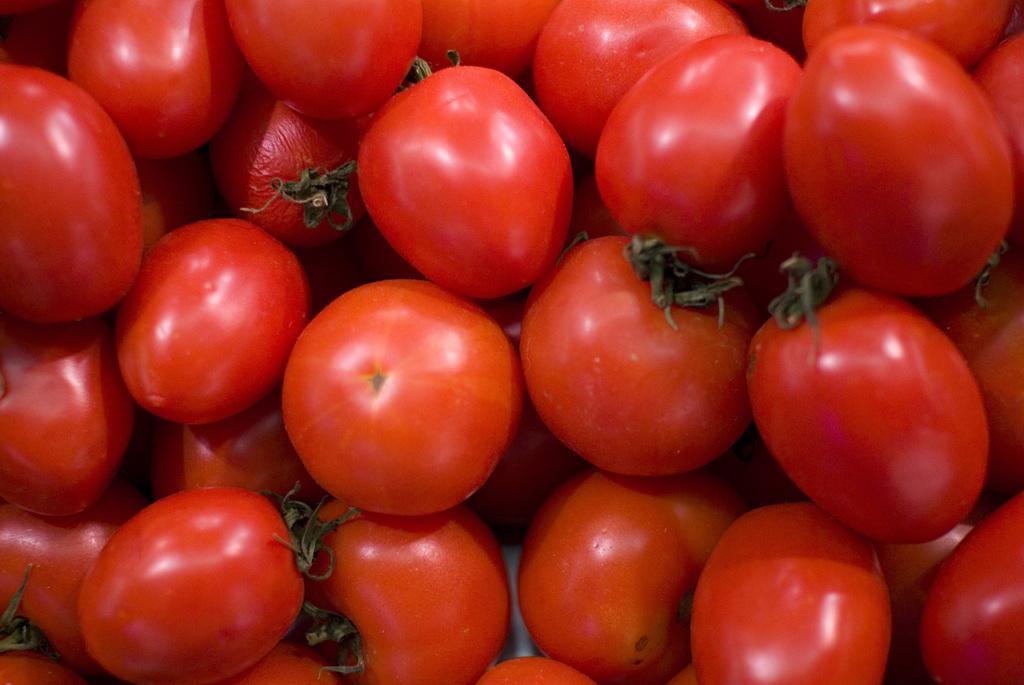How would you summarize this image in a sentence or two? In this picture there are few tomatoes which are in red color. 